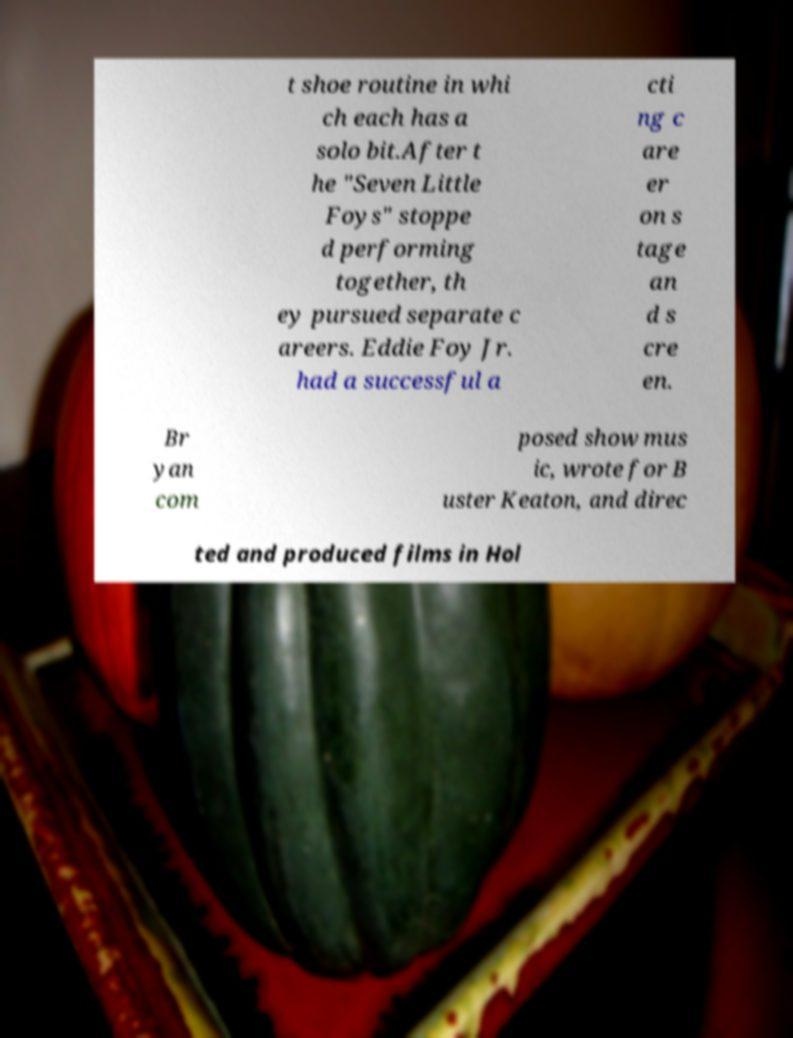Please read and relay the text visible in this image. What does it say? t shoe routine in whi ch each has a solo bit.After t he "Seven Little Foys" stoppe d performing together, th ey pursued separate c areers. Eddie Foy Jr. had a successful a cti ng c are er on s tage an d s cre en. Br yan com posed show mus ic, wrote for B uster Keaton, and direc ted and produced films in Hol 